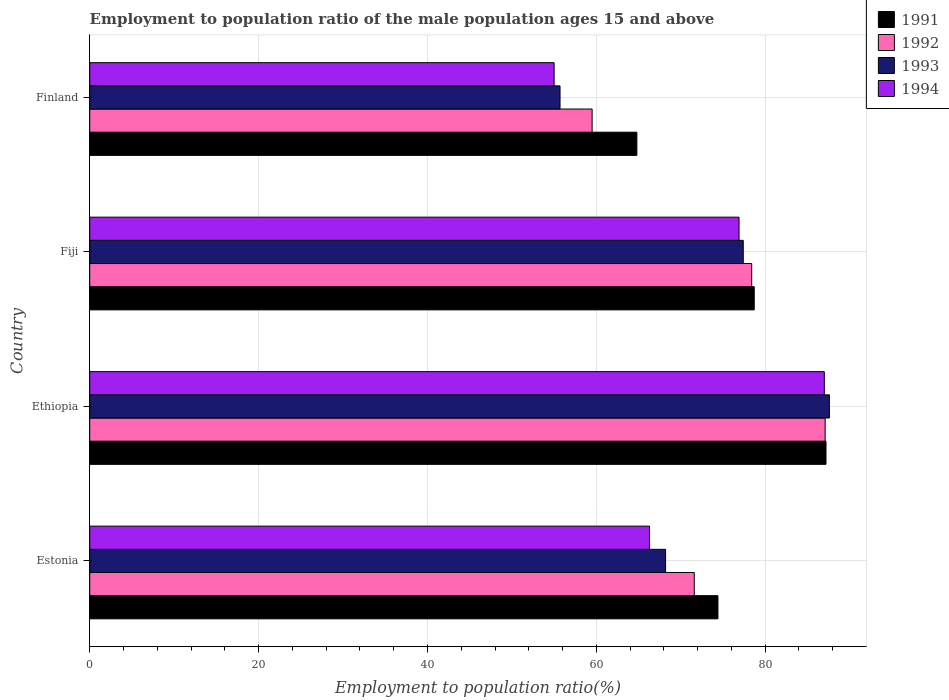How many different coloured bars are there?
Provide a short and direct response. 4. Are the number of bars per tick equal to the number of legend labels?
Offer a terse response. Yes. How many bars are there on the 2nd tick from the top?
Make the answer very short. 4. What is the label of the 2nd group of bars from the top?
Offer a terse response. Fiji. In how many cases, is the number of bars for a given country not equal to the number of legend labels?
Your response must be concise. 0. What is the employment to population ratio in 1994 in Ethiopia?
Ensure brevity in your answer.  87. Across all countries, what is the maximum employment to population ratio in 1991?
Make the answer very short. 87.2. Across all countries, what is the minimum employment to population ratio in 1992?
Give a very brief answer. 59.5. In which country was the employment to population ratio in 1992 maximum?
Your response must be concise. Ethiopia. What is the total employment to population ratio in 1993 in the graph?
Your response must be concise. 288.9. What is the difference between the employment to population ratio in 1994 in Ethiopia and that in Fiji?
Offer a terse response. 10.1. What is the difference between the employment to population ratio in 1991 in Estonia and the employment to population ratio in 1992 in Ethiopia?
Provide a succinct answer. -12.7. What is the average employment to population ratio in 1994 per country?
Keep it short and to the point. 71.3. What is the difference between the employment to population ratio in 1992 and employment to population ratio in 1994 in Estonia?
Offer a terse response. 5.3. In how many countries, is the employment to population ratio in 1992 greater than 48 %?
Make the answer very short. 4. What is the ratio of the employment to population ratio in 1994 in Ethiopia to that in Fiji?
Provide a short and direct response. 1.13. Is the employment to population ratio in 1993 in Estonia less than that in Ethiopia?
Your answer should be very brief. Yes. Is the difference between the employment to population ratio in 1992 in Estonia and Ethiopia greater than the difference between the employment to population ratio in 1994 in Estonia and Ethiopia?
Your answer should be very brief. Yes. What is the difference between the highest and the second highest employment to population ratio in 1993?
Offer a terse response. 10.2. What is the difference between the highest and the lowest employment to population ratio in 1991?
Your answer should be compact. 22.4. In how many countries, is the employment to population ratio in 1992 greater than the average employment to population ratio in 1992 taken over all countries?
Your response must be concise. 2. Is the sum of the employment to population ratio in 1993 in Ethiopia and Finland greater than the maximum employment to population ratio in 1992 across all countries?
Give a very brief answer. Yes. What does the 3rd bar from the top in Finland represents?
Give a very brief answer. 1992. What does the 4th bar from the bottom in Finland represents?
Give a very brief answer. 1994. Is it the case that in every country, the sum of the employment to population ratio in 1993 and employment to population ratio in 1992 is greater than the employment to population ratio in 1991?
Make the answer very short. Yes. What is the difference between two consecutive major ticks on the X-axis?
Offer a terse response. 20. Does the graph contain grids?
Your response must be concise. Yes. What is the title of the graph?
Your answer should be compact. Employment to population ratio of the male population ages 15 and above. Does "1967" appear as one of the legend labels in the graph?
Your answer should be compact. No. What is the label or title of the Y-axis?
Offer a terse response. Country. What is the Employment to population ratio(%) in 1991 in Estonia?
Your response must be concise. 74.4. What is the Employment to population ratio(%) of 1992 in Estonia?
Keep it short and to the point. 71.6. What is the Employment to population ratio(%) in 1993 in Estonia?
Make the answer very short. 68.2. What is the Employment to population ratio(%) in 1994 in Estonia?
Keep it short and to the point. 66.3. What is the Employment to population ratio(%) in 1991 in Ethiopia?
Ensure brevity in your answer.  87.2. What is the Employment to population ratio(%) in 1992 in Ethiopia?
Keep it short and to the point. 87.1. What is the Employment to population ratio(%) in 1993 in Ethiopia?
Your answer should be very brief. 87.6. What is the Employment to population ratio(%) of 1991 in Fiji?
Offer a very short reply. 78.7. What is the Employment to population ratio(%) of 1992 in Fiji?
Make the answer very short. 78.4. What is the Employment to population ratio(%) of 1993 in Fiji?
Give a very brief answer. 77.4. What is the Employment to population ratio(%) in 1994 in Fiji?
Offer a terse response. 76.9. What is the Employment to population ratio(%) of 1991 in Finland?
Provide a short and direct response. 64.8. What is the Employment to population ratio(%) of 1992 in Finland?
Your answer should be compact. 59.5. What is the Employment to population ratio(%) in 1993 in Finland?
Your response must be concise. 55.7. Across all countries, what is the maximum Employment to population ratio(%) in 1991?
Offer a very short reply. 87.2. Across all countries, what is the maximum Employment to population ratio(%) of 1992?
Make the answer very short. 87.1. Across all countries, what is the maximum Employment to population ratio(%) of 1993?
Make the answer very short. 87.6. Across all countries, what is the maximum Employment to population ratio(%) in 1994?
Your response must be concise. 87. Across all countries, what is the minimum Employment to population ratio(%) in 1991?
Keep it short and to the point. 64.8. Across all countries, what is the minimum Employment to population ratio(%) in 1992?
Provide a succinct answer. 59.5. Across all countries, what is the minimum Employment to population ratio(%) in 1993?
Keep it short and to the point. 55.7. Across all countries, what is the minimum Employment to population ratio(%) in 1994?
Provide a succinct answer. 55. What is the total Employment to population ratio(%) of 1991 in the graph?
Offer a very short reply. 305.1. What is the total Employment to population ratio(%) of 1992 in the graph?
Offer a very short reply. 296.6. What is the total Employment to population ratio(%) in 1993 in the graph?
Offer a terse response. 288.9. What is the total Employment to population ratio(%) in 1994 in the graph?
Keep it short and to the point. 285.2. What is the difference between the Employment to population ratio(%) in 1991 in Estonia and that in Ethiopia?
Offer a very short reply. -12.8. What is the difference between the Employment to population ratio(%) of 1992 in Estonia and that in Ethiopia?
Give a very brief answer. -15.5. What is the difference between the Employment to population ratio(%) of 1993 in Estonia and that in Ethiopia?
Ensure brevity in your answer.  -19.4. What is the difference between the Employment to population ratio(%) of 1994 in Estonia and that in Ethiopia?
Offer a terse response. -20.7. What is the difference between the Employment to population ratio(%) of 1993 in Estonia and that in Fiji?
Keep it short and to the point. -9.2. What is the difference between the Employment to population ratio(%) of 1992 in Estonia and that in Finland?
Keep it short and to the point. 12.1. What is the difference between the Employment to population ratio(%) of 1994 in Estonia and that in Finland?
Keep it short and to the point. 11.3. What is the difference between the Employment to population ratio(%) of 1991 in Ethiopia and that in Fiji?
Your answer should be compact. 8.5. What is the difference between the Employment to population ratio(%) in 1992 in Ethiopia and that in Fiji?
Offer a very short reply. 8.7. What is the difference between the Employment to population ratio(%) in 1994 in Ethiopia and that in Fiji?
Make the answer very short. 10.1. What is the difference between the Employment to population ratio(%) of 1991 in Ethiopia and that in Finland?
Make the answer very short. 22.4. What is the difference between the Employment to population ratio(%) in 1992 in Ethiopia and that in Finland?
Offer a terse response. 27.6. What is the difference between the Employment to population ratio(%) of 1993 in Ethiopia and that in Finland?
Offer a terse response. 31.9. What is the difference between the Employment to population ratio(%) in 1993 in Fiji and that in Finland?
Give a very brief answer. 21.7. What is the difference between the Employment to population ratio(%) in 1994 in Fiji and that in Finland?
Your answer should be compact. 21.9. What is the difference between the Employment to population ratio(%) in 1991 in Estonia and the Employment to population ratio(%) in 1992 in Ethiopia?
Keep it short and to the point. -12.7. What is the difference between the Employment to population ratio(%) of 1991 in Estonia and the Employment to population ratio(%) of 1994 in Ethiopia?
Offer a terse response. -12.6. What is the difference between the Employment to population ratio(%) of 1992 in Estonia and the Employment to population ratio(%) of 1994 in Ethiopia?
Keep it short and to the point. -15.4. What is the difference between the Employment to population ratio(%) of 1993 in Estonia and the Employment to population ratio(%) of 1994 in Ethiopia?
Your answer should be very brief. -18.8. What is the difference between the Employment to population ratio(%) in 1992 in Estonia and the Employment to population ratio(%) in 1993 in Fiji?
Make the answer very short. -5.8. What is the difference between the Employment to population ratio(%) in 1993 in Estonia and the Employment to population ratio(%) in 1994 in Fiji?
Ensure brevity in your answer.  -8.7. What is the difference between the Employment to population ratio(%) of 1991 in Estonia and the Employment to population ratio(%) of 1993 in Finland?
Ensure brevity in your answer.  18.7. What is the difference between the Employment to population ratio(%) of 1991 in Estonia and the Employment to population ratio(%) of 1994 in Finland?
Offer a terse response. 19.4. What is the difference between the Employment to population ratio(%) in 1992 in Estonia and the Employment to population ratio(%) in 1993 in Finland?
Keep it short and to the point. 15.9. What is the difference between the Employment to population ratio(%) of 1993 in Ethiopia and the Employment to population ratio(%) of 1994 in Fiji?
Provide a succinct answer. 10.7. What is the difference between the Employment to population ratio(%) in 1991 in Ethiopia and the Employment to population ratio(%) in 1992 in Finland?
Ensure brevity in your answer.  27.7. What is the difference between the Employment to population ratio(%) of 1991 in Ethiopia and the Employment to population ratio(%) of 1993 in Finland?
Offer a very short reply. 31.5. What is the difference between the Employment to population ratio(%) of 1991 in Ethiopia and the Employment to population ratio(%) of 1994 in Finland?
Make the answer very short. 32.2. What is the difference between the Employment to population ratio(%) in 1992 in Ethiopia and the Employment to population ratio(%) in 1993 in Finland?
Your response must be concise. 31.4. What is the difference between the Employment to population ratio(%) of 1992 in Ethiopia and the Employment to population ratio(%) of 1994 in Finland?
Make the answer very short. 32.1. What is the difference between the Employment to population ratio(%) in 1993 in Ethiopia and the Employment to population ratio(%) in 1994 in Finland?
Provide a short and direct response. 32.6. What is the difference between the Employment to population ratio(%) of 1991 in Fiji and the Employment to population ratio(%) of 1994 in Finland?
Your answer should be very brief. 23.7. What is the difference between the Employment to population ratio(%) in 1992 in Fiji and the Employment to population ratio(%) in 1993 in Finland?
Ensure brevity in your answer.  22.7. What is the difference between the Employment to population ratio(%) in 1992 in Fiji and the Employment to population ratio(%) in 1994 in Finland?
Give a very brief answer. 23.4. What is the difference between the Employment to population ratio(%) of 1993 in Fiji and the Employment to population ratio(%) of 1994 in Finland?
Your answer should be very brief. 22.4. What is the average Employment to population ratio(%) in 1991 per country?
Make the answer very short. 76.28. What is the average Employment to population ratio(%) in 1992 per country?
Keep it short and to the point. 74.15. What is the average Employment to population ratio(%) of 1993 per country?
Offer a very short reply. 72.22. What is the average Employment to population ratio(%) of 1994 per country?
Make the answer very short. 71.3. What is the difference between the Employment to population ratio(%) in 1991 and Employment to population ratio(%) in 1992 in Estonia?
Your response must be concise. 2.8. What is the difference between the Employment to population ratio(%) in 1991 and Employment to population ratio(%) in 1994 in Estonia?
Your response must be concise. 8.1. What is the difference between the Employment to population ratio(%) in 1992 and Employment to population ratio(%) in 1994 in Estonia?
Offer a terse response. 5.3. What is the difference between the Employment to population ratio(%) of 1993 and Employment to population ratio(%) of 1994 in Estonia?
Ensure brevity in your answer.  1.9. What is the difference between the Employment to population ratio(%) in 1991 and Employment to population ratio(%) in 1994 in Ethiopia?
Provide a short and direct response. 0.2. What is the difference between the Employment to population ratio(%) of 1992 and Employment to population ratio(%) of 1993 in Ethiopia?
Keep it short and to the point. -0.5. What is the difference between the Employment to population ratio(%) in 1993 and Employment to population ratio(%) in 1994 in Ethiopia?
Your response must be concise. 0.6. What is the difference between the Employment to population ratio(%) of 1991 and Employment to population ratio(%) of 1992 in Fiji?
Provide a short and direct response. 0.3. What is the difference between the Employment to population ratio(%) of 1991 and Employment to population ratio(%) of 1993 in Fiji?
Your response must be concise. 1.3. What is the difference between the Employment to population ratio(%) in 1991 and Employment to population ratio(%) in 1994 in Fiji?
Make the answer very short. 1.8. What is the difference between the Employment to population ratio(%) in 1992 and Employment to population ratio(%) in 1993 in Fiji?
Offer a terse response. 1. What is the difference between the Employment to population ratio(%) of 1992 and Employment to population ratio(%) of 1994 in Fiji?
Ensure brevity in your answer.  1.5. What is the difference between the Employment to population ratio(%) of 1991 and Employment to population ratio(%) of 1993 in Finland?
Your answer should be compact. 9.1. What is the difference between the Employment to population ratio(%) of 1992 and Employment to population ratio(%) of 1993 in Finland?
Give a very brief answer. 3.8. What is the difference between the Employment to population ratio(%) of 1993 and Employment to population ratio(%) of 1994 in Finland?
Make the answer very short. 0.7. What is the ratio of the Employment to population ratio(%) of 1991 in Estonia to that in Ethiopia?
Your response must be concise. 0.85. What is the ratio of the Employment to population ratio(%) in 1992 in Estonia to that in Ethiopia?
Your answer should be compact. 0.82. What is the ratio of the Employment to population ratio(%) in 1993 in Estonia to that in Ethiopia?
Provide a succinct answer. 0.78. What is the ratio of the Employment to population ratio(%) of 1994 in Estonia to that in Ethiopia?
Give a very brief answer. 0.76. What is the ratio of the Employment to population ratio(%) in 1991 in Estonia to that in Fiji?
Your answer should be compact. 0.95. What is the ratio of the Employment to population ratio(%) of 1992 in Estonia to that in Fiji?
Provide a succinct answer. 0.91. What is the ratio of the Employment to population ratio(%) of 1993 in Estonia to that in Fiji?
Offer a very short reply. 0.88. What is the ratio of the Employment to population ratio(%) in 1994 in Estonia to that in Fiji?
Your answer should be compact. 0.86. What is the ratio of the Employment to population ratio(%) in 1991 in Estonia to that in Finland?
Make the answer very short. 1.15. What is the ratio of the Employment to population ratio(%) in 1992 in Estonia to that in Finland?
Offer a terse response. 1.2. What is the ratio of the Employment to population ratio(%) in 1993 in Estonia to that in Finland?
Offer a terse response. 1.22. What is the ratio of the Employment to population ratio(%) of 1994 in Estonia to that in Finland?
Your response must be concise. 1.21. What is the ratio of the Employment to population ratio(%) of 1991 in Ethiopia to that in Fiji?
Offer a very short reply. 1.11. What is the ratio of the Employment to population ratio(%) of 1992 in Ethiopia to that in Fiji?
Ensure brevity in your answer.  1.11. What is the ratio of the Employment to population ratio(%) in 1993 in Ethiopia to that in Fiji?
Offer a terse response. 1.13. What is the ratio of the Employment to population ratio(%) of 1994 in Ethiopia to that in Fiji?
Ensure brevity in your answer.  1.13. What is the ratio of the Employment to population ratio(%) of 1991 in Ethiopia to that in Finland?
Provide a short and direct response. 1.35. What is the ratio of the Employment to population ratio(%) in 1992 in Ethiopia to that in Finland?
Provide a succinct answer. 1.46. What is the ratio of the Employment to population ratio(%) in 1993 in Ethiopia to that in Finland?
Offer a terse response. 1.57. What is the ratio of the Employment to population ratio(%) in 1994 in Ethiopia to that in Finland?
Offer a terse response. 1.58. What is the ratio of the Employment to population ratio(%) in 1991 in Fiji to that in Finland?
Offer a very short reply. 1.21. What is the ratio of the Employment to population ratio(%) in 1992 in Fiji to that in Finland?
Provide a succinct answer. 1.32. What is the ratio of the Employment to population ratio(%) in 1993 in Fiji to that in Finland?
Provide a succinct answer. 1.39. What is the ratio of the Employment to population ratio(%) of 1994 in Fiji to that in Finland?
Provide a succinct answer. 1.4. What is the difference between the highest and the second highest Employment to population ratio(%) in 1991?
Provide a short and direct response. 8.5. What is the difference between the highest and the second highest Employment to population ratio(%) in 1993?
Your answer should be very brief. 10.2. What is the difference between the highest and the second highest Employment to population ratio(%) of 1994?
Make the answer very short. 10.1. What is the difference between the highest and the lowest Employment to population ratio(%) in 1991?
Provide a succinct answer. 22.4. What is the difference between the highest and the lowest Employment to population ratio(%) in 1992?
Your answer should be compact. 27.6. What is the difference between the highest and the lowest Employment to population ratio(%) in 1993?
Your answer should be very brief. 31.9. 